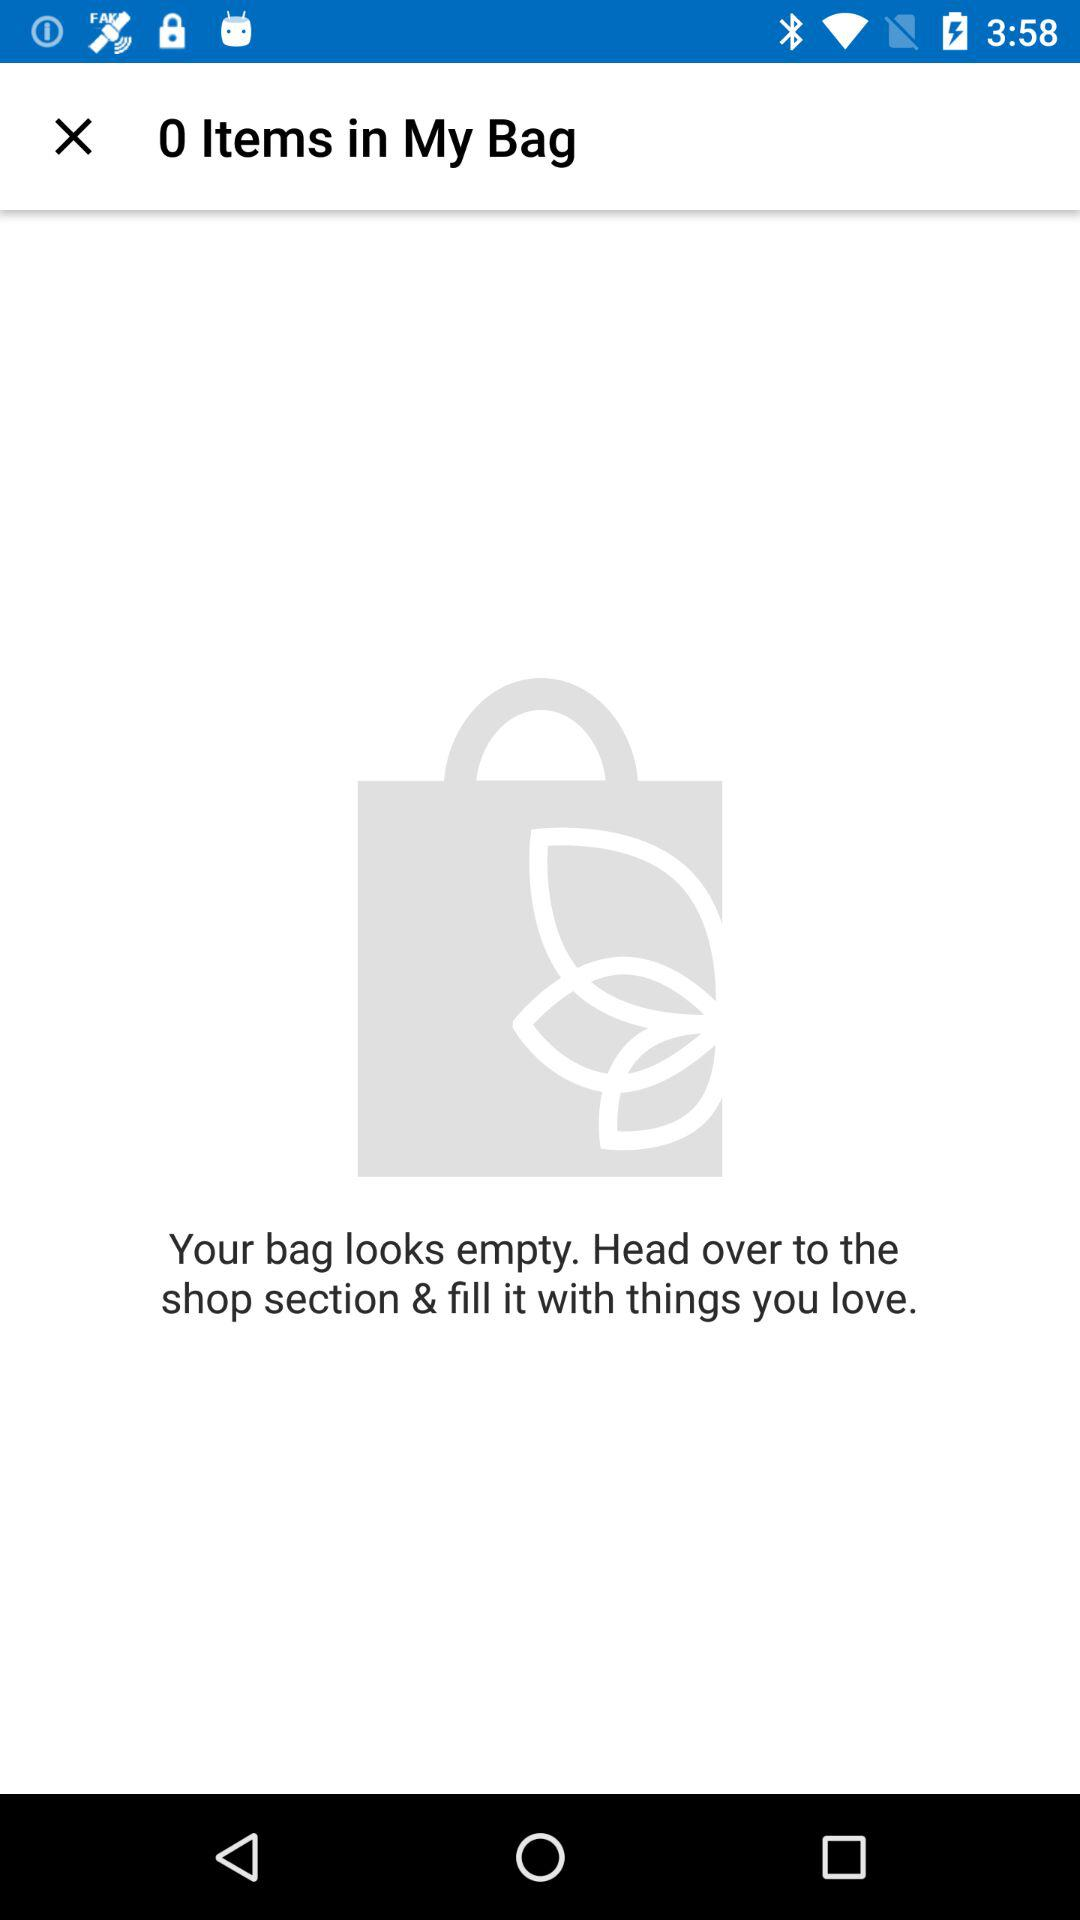Is there any item in my bag? There are no items in your bag. 